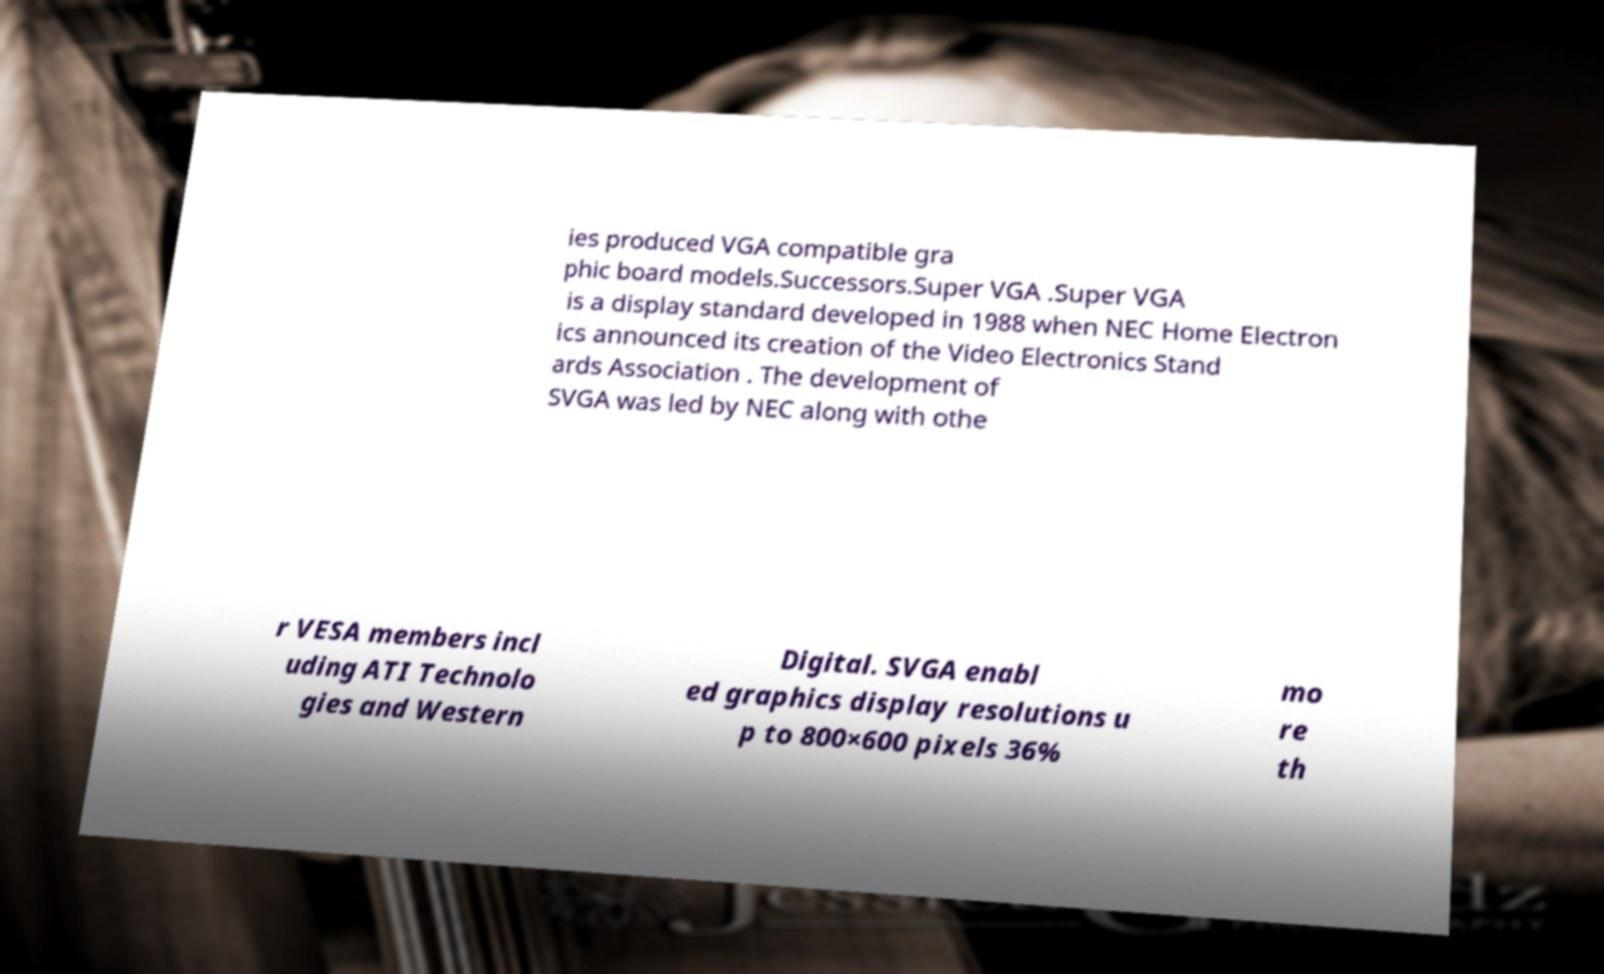For documentation purposes, I need the text within this image transcribed. Could you provide that? ies produced VGA compatible gra phic board models.Successors.Super VGA .Super VGA is a display standard developed in 1988 when NEC Home Electron ics announced its creation of the Video Electronics Stand ards Association . The development of SVGA was led by NEC along with othe r VESA members incl uding ATI Technolo gies and Western Digital. SVGA enabl ed graphics display resolutions u p to 800×600 pixels 36% mo re th 